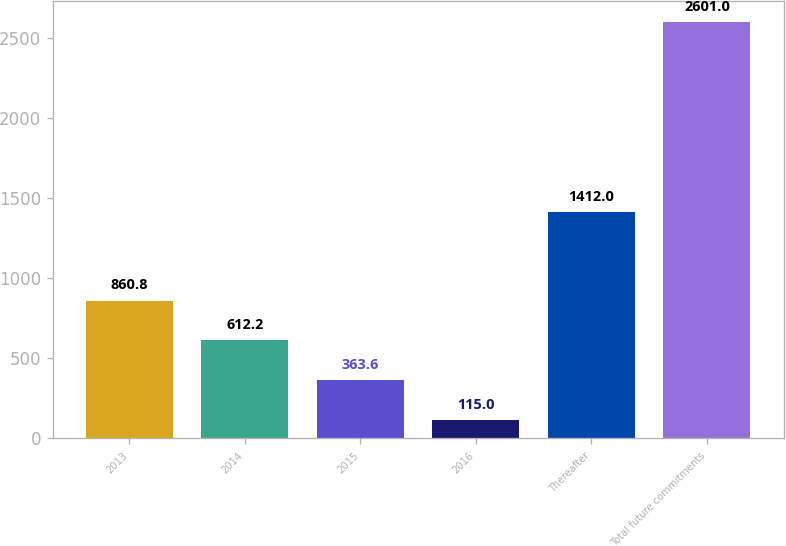Convert chart to OTSL. <chart><loc_0><loc_0><loc_500><loc_500><bar_chart><fcel>2013<fcel>2014<fcel>2015<fcel>2016<fcel>Thereafter<fcel>Total future commitments<nl><fcel>860.8<fcel>612.2<fcel>363.6<fcel>115<fcel>1412<fcel>2601<nl></chart> 